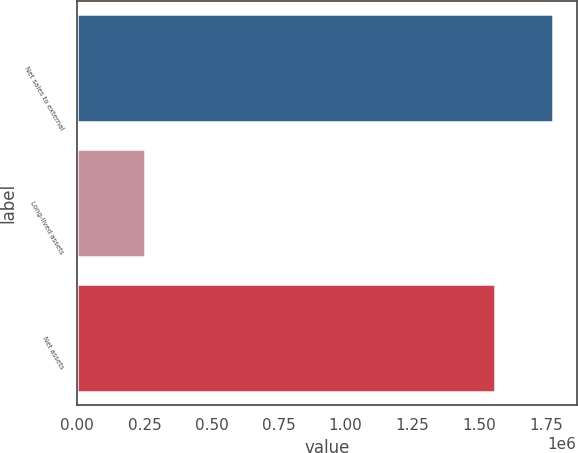Convert chart. <chart><loc_0><loc_0><loc_500><loc_500><bar_chart><fcel>Net sales to external<fcel>Long-lived assets<fcel>Net assets<nl><fcel>1.774e+06<fcel>250988<fcel>1.5579e+06<nl></chart> 